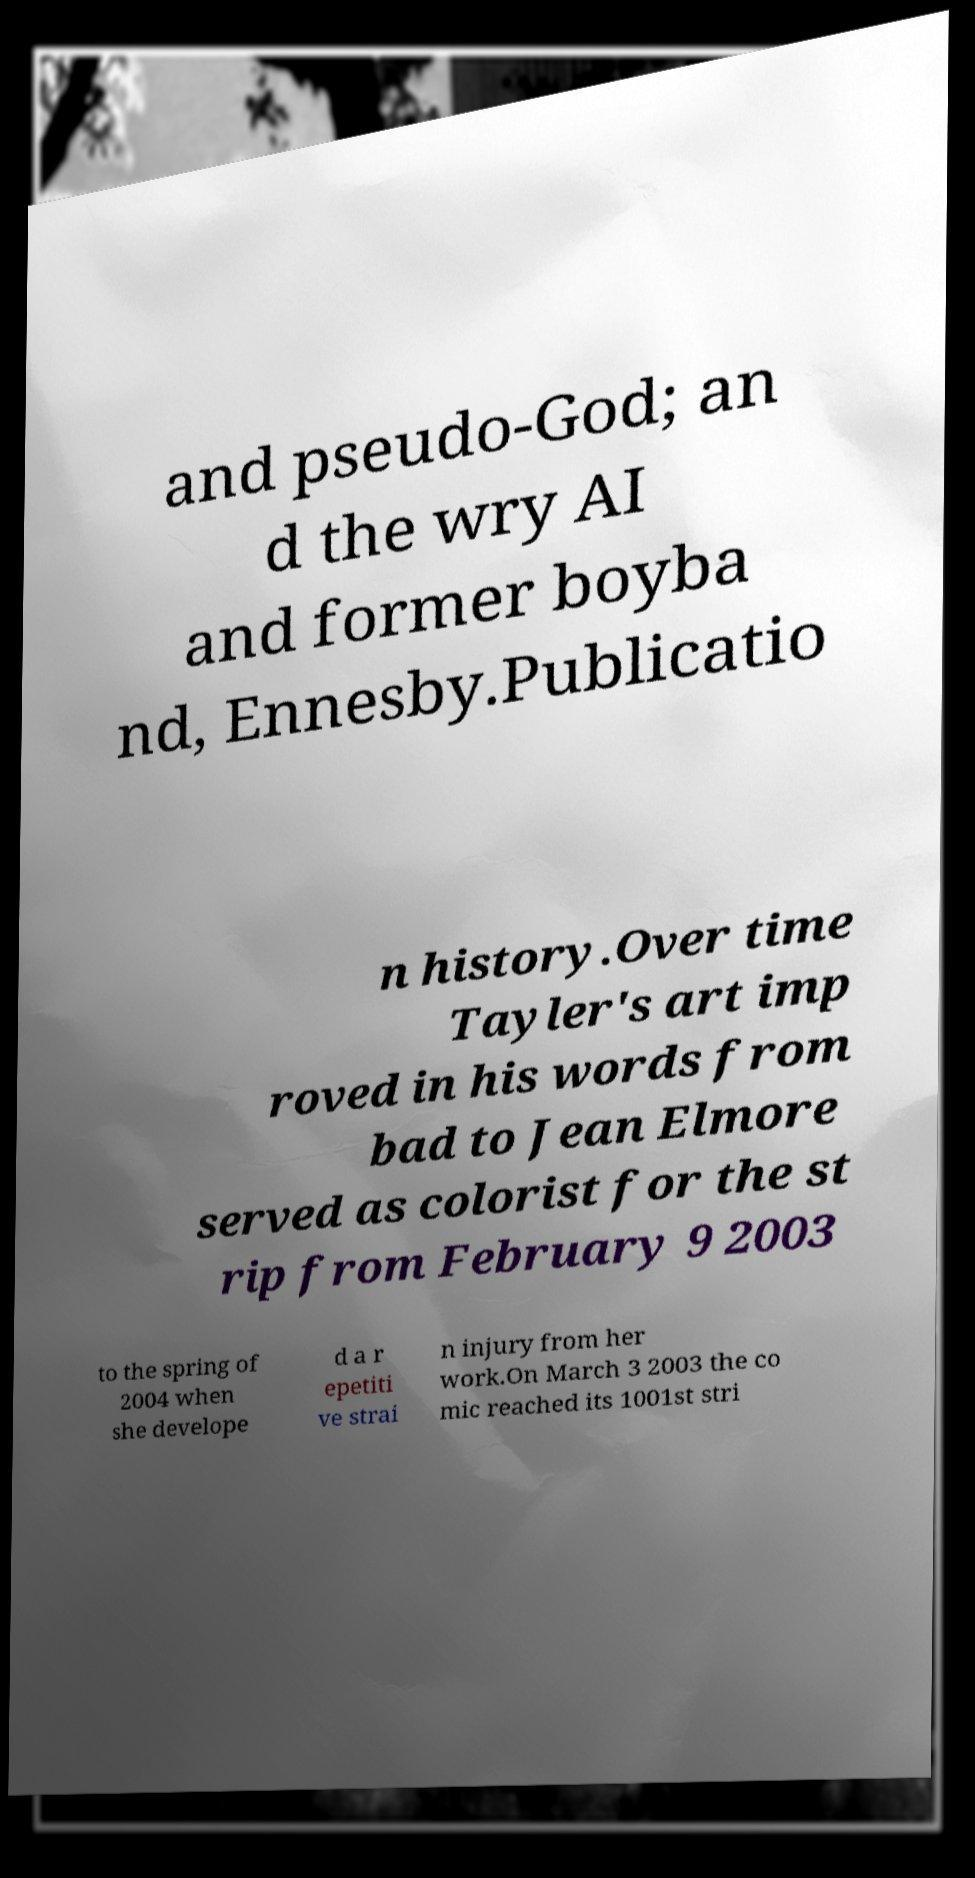Can you accurately transcribe the text from the provided image for me? and pseudo-God; an d the wry AI and former boyba nd, Ennesby.Publicatio n history.Over time Tayler's art imp roved in his words from bad to Jean Elmore served as colorist for the st rip from February 9 2003 to the spring of 2004 when she develope d a r epetiti ve strai n injury from her work.On March 3 2003 the co mic reached its 1001st stri 